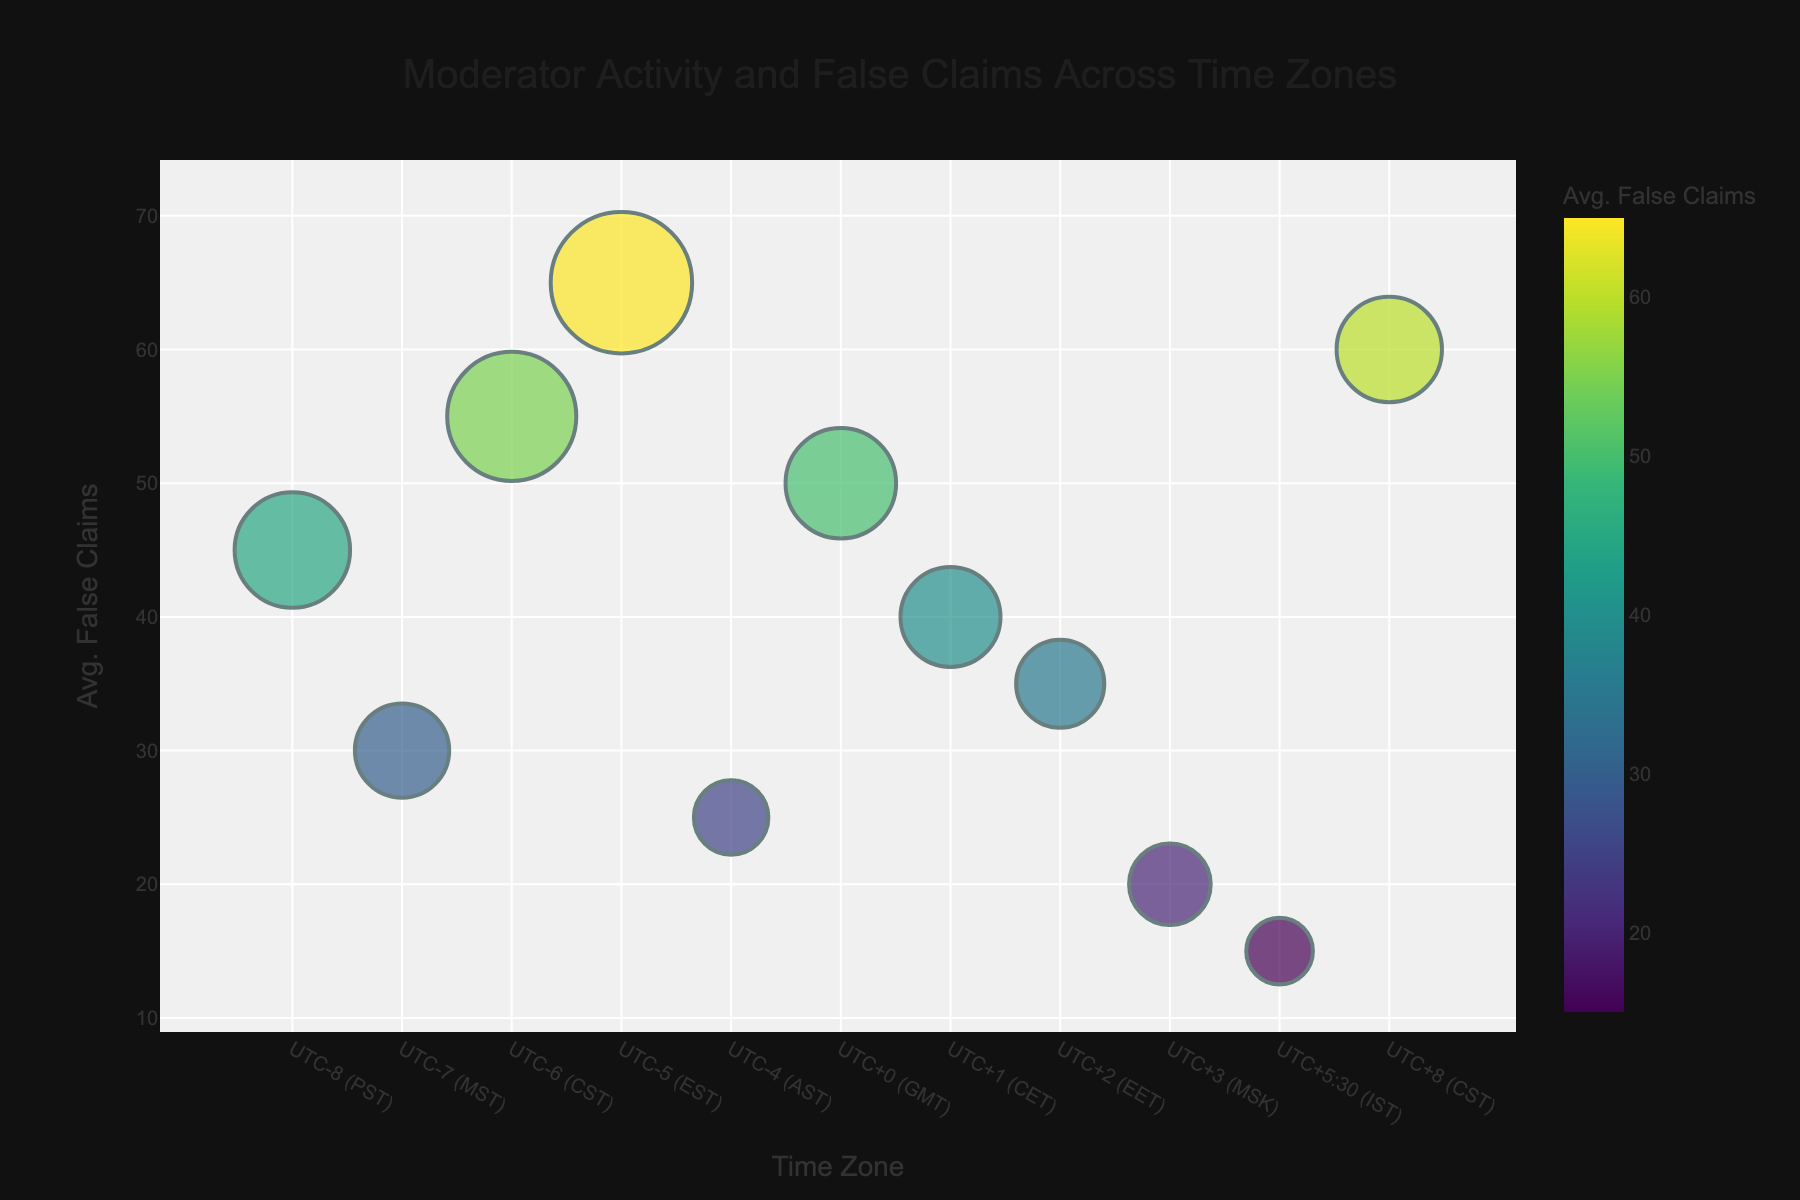what is the title of the chart? The title is displayed at the top center of the chart, and it reads "Moderator Activity and False Claims Across Time Zones".
Answer: Moderator Activity and False Claims Across Time Zones How many active moderators are in the UTC+1 (CET) time zone? Locate the bubble corresponding to UTC+1 (CET) and read the size indicator or hover over the bubble to see the details. It shows 9 active moderators.
Answer: 9 Which time zone has handled the highest average number of false claims? Identify the bubble with the highest position on the y-axis, which represents the average number of false claims handled. This is UTC-5 (EST) with 65 claims.
Answer: UTC-5 (EST) Calculate the total number of active moderators across all time zones. Sum the 'Active Moderators' for all time zones: 12+8+15+18+5+11+9+7+6+4+10 = 105.
Answer: 105 Compare the number of active moderators in UTC-8 (PST) and UTC+5:30 (IST). Which has more and by how many? Compare the values; UTC-8 (PST) has 12 active moderators, and UTC+5:30 (IST) has 4. The difference is 12 - 4 = 8 moderators.
Answer: UTC-8 (PST) by 8 Which time zone has the smallest bubble size? Identify the smallest bubble on the chart, indicating the fewest active moderators. This is UTC+5:30 (IST) with 4 moderators.
Answer: UTC+5:30 (IST) How does the average number of false claims handled in UTC+8 (CST) compare to UTC-6 (CST)? Locate the bubbles for both time zones; UTC+8 (CST) handles 60 false claims on average, while UTC-6 (CST) handles 55. UTC+8 (CST) handles 5 more.
Answer: UTC+8 (CST) by 5 Determine the average number of false claims handled in the time zones with 10 or more active moderators. Calculate the average for UTC-8 (PST, 45), UTC-6 (CST, 55), UTC-5 (EST, 65), GMT (50), and UTC+8 (CST, 60). Average = (45+55+65+50+60)/5 = 55.
Answer: 55 What is the color scheme used in the chart to represent the average false claims handled? The color scheme is indicated by the color bar and uses a gradient from lighter to darker colors reflecting the increasing average false claims. The specific name is 'Viridis'.
Answer: Viridis How many time zones have an average false claims handled greater than 50? Count the bubbles above the value 50 on the y-axis: UTC-6 (CST), UTC-5 (EST), and UTC+8 (CST). There are 3 time zones.
Answer: 3 